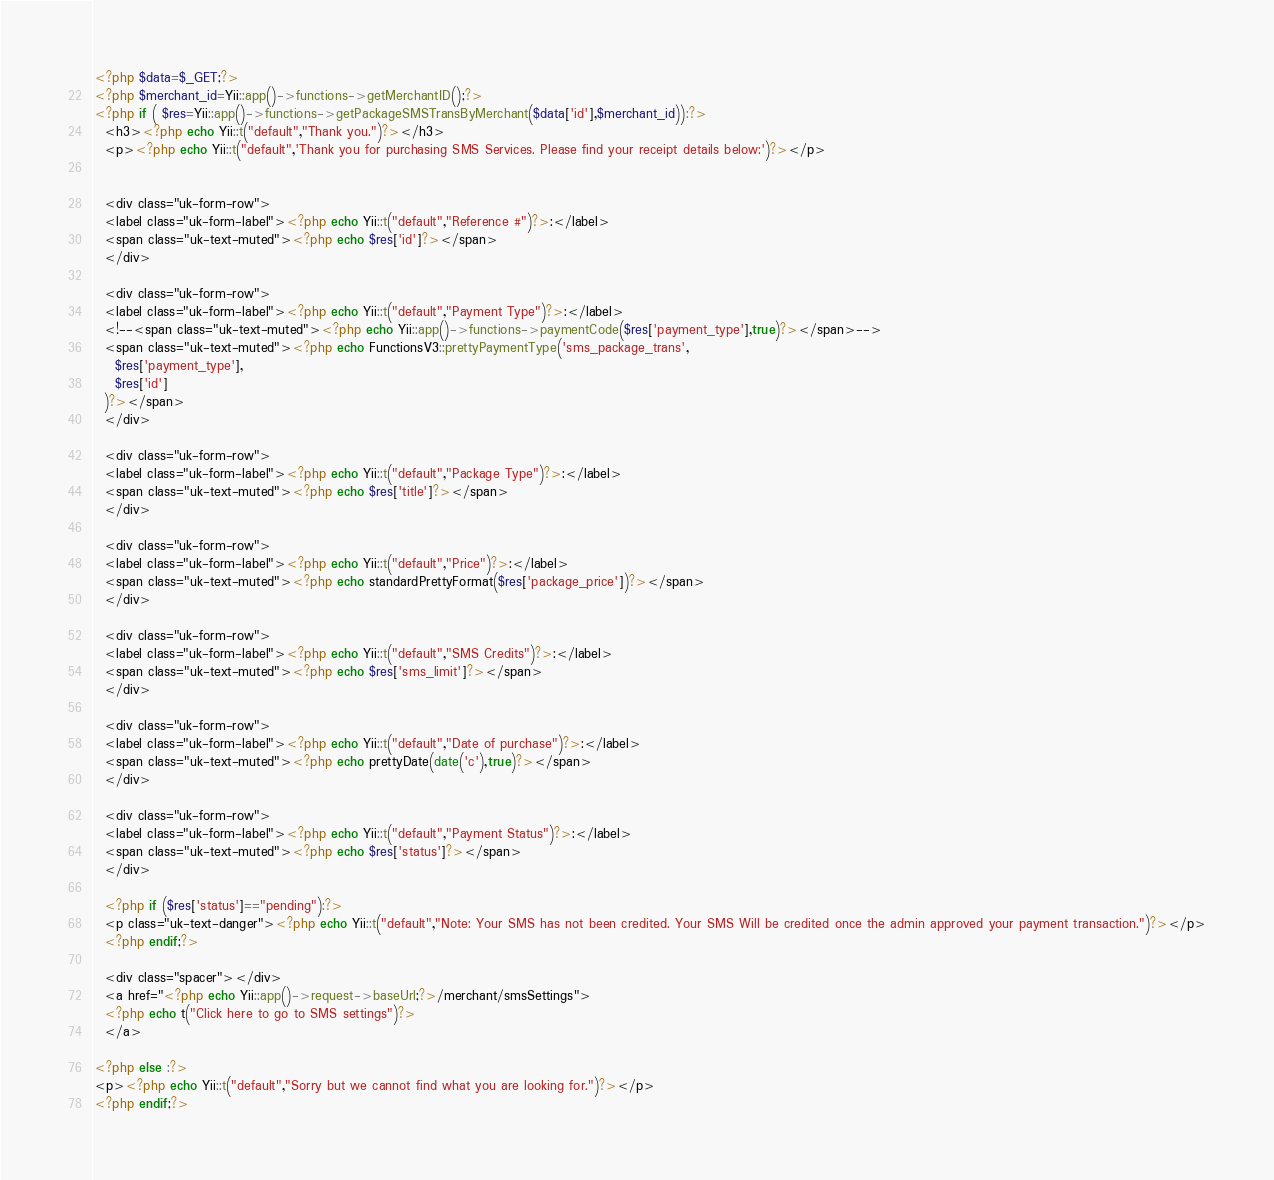<code> <loc_0><loc_0><loc_500><loc_500><_PHP_><?php $data=$_GET;?>
<?php $merchant_id=Yii::app()->functions->getMerchantID();?>
<?php if ( $res=Yii::app()->functions->getPackageSMSTransByMerchant($data['id'],$merchant_id)):?>  
  <h3><?php echo Yii::t("default","Thank you.")?></h3>
  <p><?php echo Yii::t("default",'Thank you for purchasing SMS Services. Please find your receipt details below:')?></p>
  
  
  <div class="uk-form-row">
  <label class="uk-form-label"><?php echo Yii::t("default","Reference #")?>:</label>  
  <span class="uk-text-muted"><?php echo $res['id']?></span>
  </div>
  
  <div class="uk-form-row">
  <label class="uk-form-label"><?php echo Yii::t("default","Payment Type")?>:</label>  
  <!--<span class="uk-text-muted"><?php echo Yii::app()->functions->paymentCode($res['payment_type'],true)?></span>-->
  <span class="uk-text-muted"><?php echo FunctionsV3::prettyPaymentType('sms_package_trans',
    $res['payment_type'],
    $res['id']
  )?></span>
  </div>
  
  <div class="uk-form-row">
  <label class="uk-form-label"><?php echo Yii::t("default","Package Type")?>:</label>  
  <span class="uk-text-muted"><?php echo $res['title']?></span>
  </div>
  
  <div class="uk-form-row">
  <label class="uk-form-label"><?php echo Yii::t("default","Price")?>:</label>  
  <span class="uk-text-muted"><?php echo standardPrettyFormat($res['package_price'])?></span>
  </div>
  
  <div class="uk-form-row">
  <label class="uk-form-label"><?php echo Yii::t("default","SMS Credits")?>:</label>  
  <span class="uk-text-muted"><?php echo $res['sms_limit']?></span>
  </div>
  
  <div class="uk-form-row">
  <label class="uk-form-label"><?php echo Yii::t("default","Date of purchase")?>:</label>  
  <span class="uk-text-muted"><?php echo prettyDate(date('c'),true)?></span>
  </div>
  
  <div class="uk-form-row">
  <label class="uk-form-label"><?php echo Yii::t("default","Payment Status")?>:</label>  
  <span class="uk-text-muted"><?php echo $res['status']?></span>
  </div>
  
  <?php if ($res['status']=="pending"):?>  
  <p class="uk-text-danger"><?php echo Yii::t("default","Note: Your SMS has not been credited. Your SMS Will be credited once the admin approved your payment transaction.")?></p>
  <?php endif;?>
  
  <div class="spacer"></div>
  <a href="<?php echo Yii::app()->request->baseUrl;?>/merchant/smsSettings">
  <?php echo t("Click here to go to SMS settings")?>
  </a>
  
<?php else :?>
<p><?php echo Yii::t("default","Sorry but we cannot find what you are looking for.")?></p>
<?php endif;?></code> 